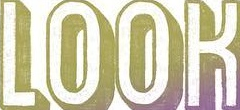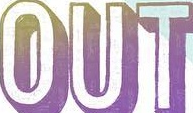Read the text from these images in sequence, separated by a semicolon. LOOK; OUT 